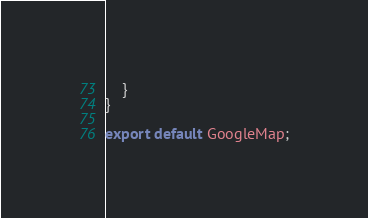Convert code to text. <code><loc_0><loc_0><loc_500><loc_500><_JavaScript_>	}
}

export default GoogleMap;</code> 